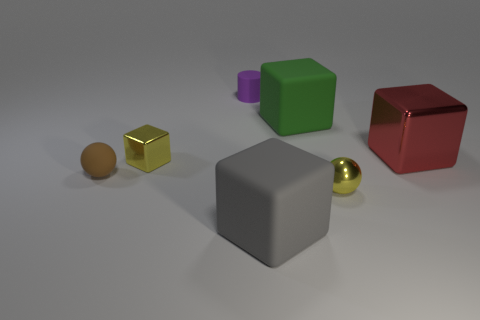Subtract 1 blocks. How many blocks are left? 3 Add 2 large metal balls. How many objects exist? 9 Subtract all cylinders. How many objects are left? 6 Add 3 small purple cylinders. How many small purple cylinders exist? 4 Subtract 0 green balls. How many objects are left? 7 Subtract all brown cubes. Subtract all small yellow objects. How many objects are left? 5 Add 1 large gray matte objects. How many large gray matte objects are left? 2 